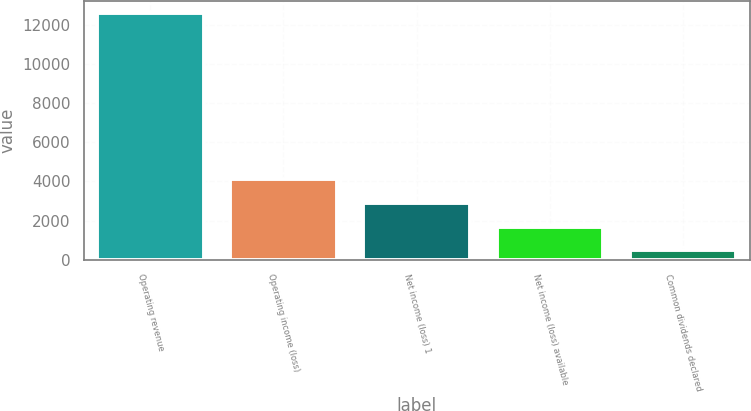Convert chart. <chart><loc_0><loc_0><loc_500><loc_500><bar_chart><fcel>Operating revenue<fcel>Operating income (loss)<fcel>Net income (loss) 1<fcel>Net income (loss) available<fcel>Common dividends declared<nl><fcel>12562<fcel>4108.8<fcel>2901.2<fcel>1693.6<fcel>486<nl></chart> 